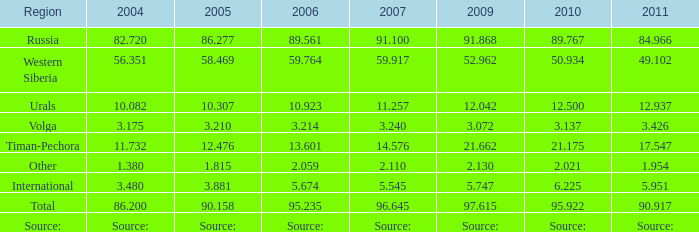Write the full table. {'header': ['Region', '2004', '2005', '2006', '2007', '2009', '2010', '2011'], 'rows': [['Russia', '82.720', '86.277', '89.561', '91.100', '91.868', '89.767', '84.966'], ['Western Siberia', '56.351', '58.469', '59.764', '59.917', '52.962', '50.934', '49.102'], ['Urals', '10.082', '10.307', '10.923', '11.257', '12.042', '12.500', '12.937'], ['Volga', '3.175', '3.210', '3.214', '3.240', '3.072', '3.137', '3.426'], ['Timan-Pechora', '11.732', '12.476', '13.601', '14.576', '21.662', '21.175', '17.547'], ['Other', '1.380', '1.815', '2.059', '2.110', '2.130', '2.021', '1.954'], ['International', '3.480', '3.881', '5.674', '5.545', '5.747', '6.225', '5.951'], ['Total', '86.200', '90.158', '95.235', '96.645', '97.615', '95.922', '90.917'], ['Source:', 'Source:', 'Source:', 'Source:', 'Source:', 'Source:', 'Source:', 'Source:']]} What is the 2007 Lukoil oil prodroduction when in 2010 oil production 3.137 million tonnes? 3.24. 